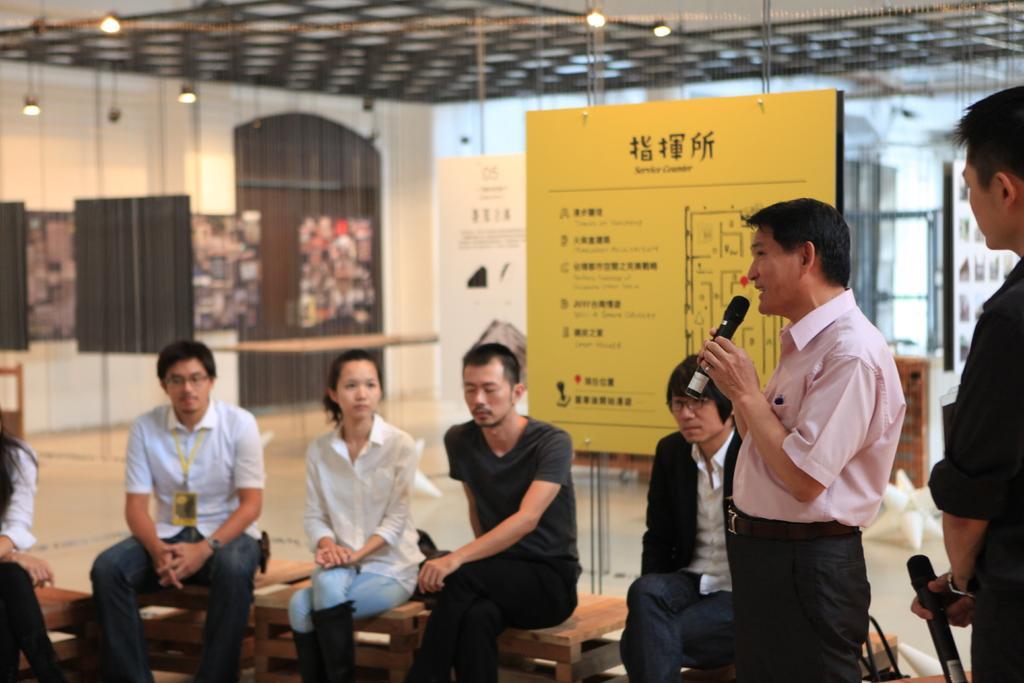Describe this image in one or two sentences. This man is holding a mic and talking. Another person is looking at this man and holding a mic. These people are sitting on benches. Background it is blur. We can see boards, lights and walls. 